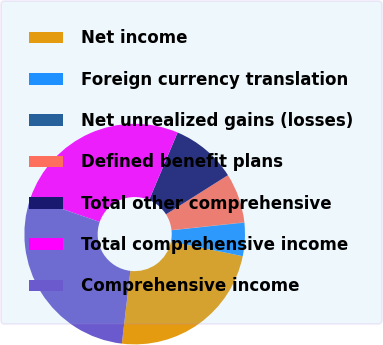Convert chart to OTSL. <chart><loc_0><loc_0><loc_500><loc_500><pie_chart><fcel>Net income<fcel>Foreign currency translation<fcel>Net unrealized gains (losses)<fcel>Defined benefit plans<fcel>Total other comprehensive<fcel>Total comprehensive income<fcel>Comprehensive income<nl><fcel>23.65%<fcel>4.86%<fcel>0.05%<fcel>7.27%<fcel>9.67%<fcel>26.05%<fcel>28.46%<nl></chart> 